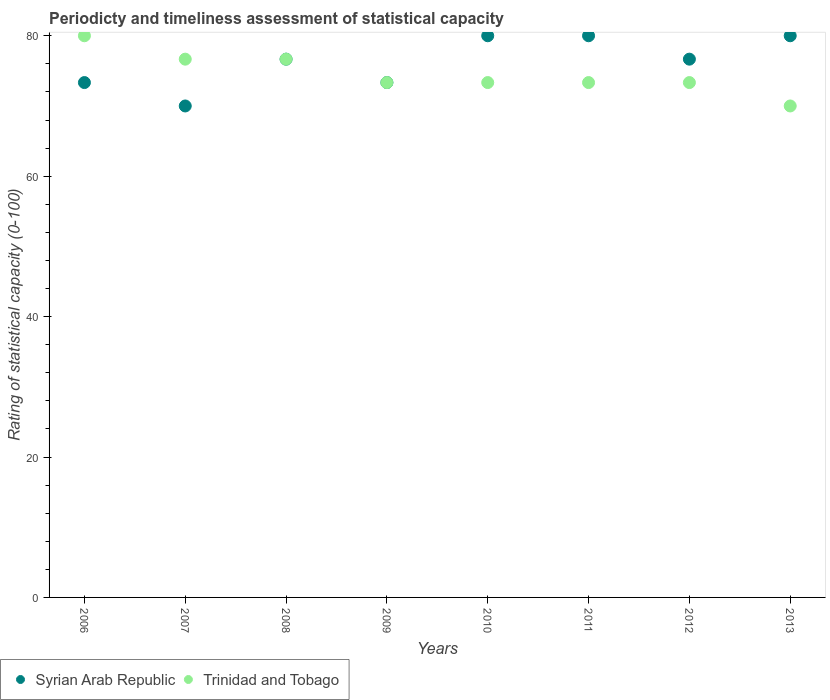Is the number of dotlines equal to the number of legend labels?
Keep it short and to the point. Yes. What is the rating of statistical capacity in Trinidad and Tobago in 2006?
Make the answer very short. 80. What is the total rating of statistical capacity in Trinidad and Tobago in the graph?
Your answer should be very brief. 596.67. What is the difference between the rating of statistical capacity in Trinidad and Tobago in 2006 and that in 2008?
Make the answer very short. 3.33. What is the difference between the rating of statistical capacity in Syrian Arab Republic in 2007 and the rating of statistical capacity in Trinidad and Tobago in 2010?
Offer a very short reply. -3.33. What is the average rating of statistical capacity in Syrian Arab Republic per year?
Your answer should be very brief. 76.25. In the year 2012, what is the difference between the rating of statistical capacity in Trinidad and Tobago and rating of statistical capacity in Syrian Arab Republic?
Your answer should be very brief. -3.33. What is the ratio of the rating of statistical capacity in Syrian Arab Republic in 2007 to that in 2010?
Make the answer very short. 0.88. Is the rating of statistical capacity in Trinidad and Tobago in 2006 less than that in 2007?
Your answer should be very brief. No. Is the difference between the rating of statistical capacity in Trinidad and Tobago in 2011 and 2012 greater than the difference between the rating of statistical capacity in Syrian Arab Republic in 2011 and 2012?
Make the answer very short. No. What is the difference between the highest and the second highest rating of statistical capacity in Syrian Arab Republic?
Keep it short and to the point. 0. What is the difference between the highest and the lowest rating of statistical capacity in Syrian Arab Republic?
Give a very brief answer. 10. In how many years, is the rating of statistical capacity in Trinidad and Tobago greater than the average rating of statistical capacity in Trinidad and Tobago taken over all years?
Offer a terse response. 3. Is the rating of statistical capacity in Trinidad and Tobago strictly less than the rating of statistical capacity in Syrian Arab Republic over the years?
Offer a very short reply. No. What is the difference between two consecutive major ticks on the Y-axis?
Your answer should be very brief. 20. Are the values on the major ticks of Y-axis written in scientific E-notation?
Offer a terse response. No. Where does the legend appear in the graph?
Keep it short and to the point. Bottom left. How many legend labels are there?
Make the answer very short. 2. How are the legend labels stacked?
Ensure brevity in your answer.  Horizontal. What is the title of the graph?
Provide a succinct answer. Periodicty and timeliness assessment of statistical capacity. What is the label or title of the X-axis?
Your answer should be very brief. Years. What is the label or title of the Y-axis?
Make the answer very short. Rating of statistical capacity (0-100). What is the Rating of statistical capacity (0-100) in Syrian Arab Republic in 2006?
Your answer should be very brief. 73.33. What is the Rating of statistical capacity (0-100) of Syrian Arab Republic in 2007?
Ensure brevity in your answer.  70. What is the Rating of statistical capacity (0-100) in Trinidad and Tobago in 2007?
Provide a short and direct response. 76.67. What is the Rating of statistical capacity (0-100) in Syrian Arab Republic in 2008?
Your answer should be very brief. 76.67. What is the Rating of statistical capacity (0-100) in Trinidad and Tobago in 2008?
Provide a succinct answer. 76.67. What is the Rating of statistical capacity (0-100) of Syrian Arab Republic in 2009?
Ensure brevity in your answer.  73.33. What is the Rating of statistical capacity (0-100) of Trinidad and Tobago in 2009?
Give a very brief answer. 73.33. What is the Rating of statistical capacity (0-100) in Syrian Arab Republic in 2010?
Make the answer very short. 80. What is the Rating of statistical capacity (0-100) in Trinidad and Tobago in 2010?
Offer a terse response. 73.33. What is the Rating of statistical capacity (0-100) of Syrian Arab Republic in 2011?
Ensure brevity in your answer.  80. What is the Rating of statistical capacity (0-100) of Trinidad and Tobago in 2011?
Your answer should be very brief. 73.33. What is the Rating of statistical capacity (0-100) in Syrian Arab Republic in 2012?
Give a very brief answer. 76.67. What is the Rating of statistical capacity (0-100) in Trinidad and Tobago in 2012?
Provide a succinct answer. 73.33. What is the Rating of statistical capacity (0-100) of Syrian Arab Republic in 2013?
Your response must be concise. 80. What is the Rating of statistical capacity (0-100) of Trinidad and Tobago in 2013?
Ensure brevity in your answer.  70. Across all years, what is the maximum Rating of statistical capacity (0-100) of Trinidad and Tobago?
Offer a terse response. 80. Across all years, what is the minimum Rating of statistical capacity (0-100) of Syrian Arab Republic?
Offer a terse response. 70. Across all years, what is the minimum Rating of statistical capacity (0-100) in Trinidad and Tobago?
Your answer should be very brief. 70. What is the total Rating of statistical capacity (0-100) in Syrian Arab Republic in the graph?
Give a very brief answer. 610. What is the total Rating of statistical capacity (0-100) in Trinidad and Tobago in the graph?
Make the answer very short. 596.67. What is the difference between the Rating of statistical capacity (0-100) in Syrian Arab Republic in 2006 and that in 2007?
Provide a succinct answer. 3.33. What is the difference between the Rating of statistical capacity (0-100) of Trinidad and Tobago in 2006 and that in 2007?
Your answer should be very brief. 3.33. What is the difference between the Rating of statistical capacity (0-100) in Syrian Arab Republic in 2006 and that in 2008?
Provide a short and direct response. -3.33. What is the difference between the Rating of statistical capacity (0-100) in Syrian Arab Republic in 2006 and that in 2010?
Offer a terse response. -6.67. What is the difference between the Rating of statistical capacity (0-100) in Syrian Arab Republic in 2006 and that in 2011?
Offer a very short reply. -6.67. What is the difference between the Rating of statistical capacity (0-100) of Trinidad and Tobago in 2006 and that in 2011?
Provide a short and direct response. 6.67. What is the difference between the Rating of statistical capacity (0-100) of Syrian Arab Republic in 2006 and that in 2012?
Your answer should be very brief. -3.33. What is the difference between the Rating of statistical capacity (0-100) in Syrian Arab Republic in 2006 and that in 2013?
Offer a terse response. -6.67. What is the difference between the Rating of statistical capacity (0-100) of Trinidad and Tobago in 2006 and that in 2013?
Your answer should be compact. 10. What is the difference between the Rating of statistical capacity (0-100) in Syrian Arab Republic in 2007 and that in 2008?
Offer a very short reply. -6.67. What is the difference between the Rating of statistical capacity (0-100) of Trinidad and Tobago in 2007 and that in 2009?
Your response must be concise. 3.33. What is the difference between the Rating of statistical capacity (0-100) of Syrian Arab Republic in 2007 and that in 2010?
Give a very brief answer. -10. What is the difference between the Rating of statistical capacity (0-100) in Trinidad and Tobago in 2007 and that in 2010?
Make the answer very short. 3.33. What is the difference between the Rating of statistical capacity (0-100) of Syrian Arab Republic in 2007 and that in 2011?
Make the answer very short. -10. What is the difference between the Rating of statistical capacity (0-100) in Syrian Arab Republic in 2007 and that in 2012?
Your answer should be very brief. -6.67. What is the difference between the Rating of statistical capacity (0-100) of Syrian Arab Republic in 2008 and that in 2009?
Offer a very short reply. 3.33. What is the difference between the Rating of statistical capacity (0-100) in Trinidad and Tobago in 2008 and that in 2009?
Your answer should be compact. 3.33. What is the difference between the Rating of statistical capacity (0-100) in Syrian Arab Republic in 2008 and that in 2010?
Keep it short and to the point. -3.33. What is the difference between the Rating of statistical capacity (0-100) in Trinidad and Tobago in 2008 and that in 2010?
Your response must be concise. 3.33. What is the difference between the Rating of statistical capacity (0-100) of Trinidad and Tobago in 2008 and that in 2011?
Your response must be concise. 3.33. What is the difference between the Rating of statistical capacity (0-100) of Syrian Arab Republic in 2008 and that in 2013?
Your answer should be very brief. -3.33. What is the difference between the Rating of statistical capacity (0-100) of Trinidad and Tobago in 2008 and that in 2013?
Your response must be concise. 6.67. What is the difference between the Rating of statistical capacity (0-100) of Syrian Arab Republic in 2009 and that in 2010?
Your answer should be compact. -6.67. What is the difference between the Rating of statistical capacity (0-100) of Trinidad and Tobago in 2009 and that in 2010?
Your response must be concise. 0. What is the difference between the Rating of statistical capacity (0-100) of Syrian Arab Republic in 2009 and that in 2011?
Provide a short and direct response. -6.67. What is the difference between the Rating of statistical capacity (0-100) of Trinidad and Tobago in 2009 and that in 2011?
Your answer should be very brief. 0. What is the difference between the Rating of statistical capacity (0-100) in Syrian Arab Republic in 2009 and that in 2013?
Your answer should be very brief. -6.67. What is the difference between the Rating of statistical capacity (0-100) of Trinidad and Tobago in 2009 and that in 2013?
Offer a very short reply. 3.33. What is the difference between the Rating of statistical capacity (0-100) of Trinidad and Tobago in 2010 and that in 2011?
Your answer should be very brief. 0. What is the difference between the Rating of statistical capacity (0-100) in Syrian Arab Republic in 2010 and that in 2012?
Provide a short and direct response. 3.33. What is the difference between the Rating of statistical capacity (0-100) in Syrian Arab Republic in 2011 and that in 2012?
Offer a very short reply. 3.33. What is the difference between the Rating of statistical capacity (0-100) in Trinidad and Tobago in 2011 and that in 2012?
Provide a short and direct response. 0. What is the difference between the Rating of statistical capacity (0-100) in Syrian Arab Republic in 2011 and that in 2013?
Ensure brevity in your answer.  0. What is the difference between the Rating of statistical capacity (0-100) of Syrian Arab Republic in 2006 and the Rating of statistical capacity (0-100) of Trinidad and Tobago in 2010?
Offer a very short reply. 0. What is the difference between the Rating of statistical capacity (0-100) in Syrian Arab Republic in 2006 and the Rating of statistical capacity (0-100) in Trinidad and Tobago in 2011?
Keep it short and to the point. 0. What is the difference between the Rating of statistical capacity (0-100) of Syrian Arab Republic in 2007 and the Rating of statistical capacity (0-100) of Trinidad and Tobago in 2008?
Provide a short and direct response. -6.67. What is the difference between the Rating of statistical capacity (0-100) of Syrian Arab Republic in 2007 and the Rating of statistical capacity (0-100) of Trinidad and Tobago in 2012?
Offer a very short reply. -3.33. What is the difference between the Rating of statistical capacity (0-100) of Syrian Arab Republic in 2008 and the Rating of statistical capacity (0-100) of Trinidad and Tobago in 2009?
Keep it short and to the point. 3.33. What is the difference between the Rating of statistical capacity (0-100) in Syrian Arab Republic in 2008 and the Rating of statistical capacity (0-100) in Trinidad and Tobago in 2011?
Keep it short and to the point. 3.33. What is the difference between the Rating of statistical capacity (0-100) in Syrian Arab Republic in 2009 and the Rating of statistical capacity (0-100) in Trinidad and Tobago in 2010?
Your answer should be very brief. 0. What is the difference between the Rating of statistical capacity (0-100) in Syrian Arab Republic in 2009 and the Rating of statistical capacity (0-100) in Trinidad and Tobago in 2012?
Give a very brief answer. 0. What is the difference between the Rating of statistical capacity (0-100) of Syrian Arab Republic in 2009 and the Rating of statistical capacity (0-100) of Trinidad and Tobago in 2013?
Ensure brevity in your answer.  3.33. What is the difference between the Rating of statistical capacity (0-100) in Syrian Arab Republic in 2010 and the Rating of statistical capacity (0-100) in Trinidad and Tobago in 2011?
Provide a short and direct response. 6.67. What is the difference between the Rating of statistical capacity (0-100) in Syrian Arab Republic in 2010 and the Rating of statistical capacity (0-100) in Trinidad and Tobago in 2012?
Offer a very short reply. 6.67. What is the difference between the Rating of statistical capacity (0-100) of Syrian Arab Republic in 2010 and the Rating of statistical capacity (0-100) of Trinidad and Tobago in 2013?
Your answer should be very brief. 10. What is the difference between the Rating of statistical capacity (0-100) of Syrian Arab Republic in 2011 and the Rating of statistical capacity (0-100) of Trinidad and Tobago in 2012?
Offer a terse response. 6.67. What is the difference between the Rating of statistical capacity (0-100) of Syrian Arab Republic in 2011 and the Rating of statistical capacity (0-100) of Trinidad and Tobago in 2013?
Provide a short and direct response. 10. What is the difference between the Rating of statistical capacity (0-100) of Syrian Arab Republic in 2012 and the Rating of statistical capacity (0-100) of Trinidad and Tobago in 2013?
Make the answer very short. 6.67. What is the average Rating of statistical capacity (0-100) of Syrian Arab Republic per year?
Offer a very short reply. 76.25. What is the average Rating of statistical capacity (0-100) of Trinidad and Tobago per year?
Provide a succinct answer. 74.58. In the year 2006, what is the difference between the Rating of statistical capacity (0-100) of Syrian Arab Republic and Rating of statistical capacity (0-100) of Trinidad and Tobago?
Ensure brevity in your answer.  -6.67. In the year 2007, what is the difference between the Rating of statistical capacity (0-100) of Syrian Arab Republic and Rating of statistical capacity (0-100) of Trinidad and Tobago?
Give a very brief answer. -6.67. In the year 2009, what is the difference between the Rating of statistical capacity (0-100) of Syrian Arab Republic and Rating of statistical capacity (0-100) of Trinidad and Tobago?
Provide a short and direct response. 0. In the year 2011, what is the difference between the Rating of statistical capacity (0-100) in Syrian Arab Republic and Rating of statistical capacity (0-100) in Trinidad and Tobago?
Your response must be concise. 6.67. In the year 2013, what is the difference between the Rating of statistical capacity (0-100) in Syrian Arab Republic and Rating of statistical capacity (0-100) in Trinidad and Tobago?
Your answer should be compact. 10. What is the ratio of the Rating of statistical capacity (0-100) of Syrian Arab Republic in 2006 to that in 2007?
Provide a succinct answer. 1.05. What is the ratio of the Rating of statistical capacity (0-100) in Trinidad and Tobago in 2006 to that in 2007?
Offer a very short reply. 1.04. What is the ratio of the Rating of statistical capacity (0-100) in Syrian Arab Republic in 2006 to that in 2008?
Your answer should be very brief. 0.96. What is the ratio of the Rating of statistical capacity (0-100) in Trinidad and Tobago in 2006 to that in 2008?
Provide a short and direct response. 1.04. What is the ratio of the Rating of statistical capacity (0-100) in Syrian Arab Republic in 2006 to that in 2009?
Keep it short and to the point. 1. What is the ratio of the Rating of statistical capacity (0-100) of Trinidad and Tobago in 2006 to that in 2009?
Keep it short and to the point. 1.09. What is the ratio of the Rating of statistical capacity (0-100) in Syrian Arab Republic in 2006 to that in 2012?
Your answer should be very brief. 0.96. What is the ratio of the Rating of statistical capacity (0-100) of Trinidad and Tobago in 2006 to that in 2013?
Offer a very short reply. 1.14. What is the ratio of the Rating of statistical capacity (0-100) of Trinidad and Tobago in 2007 to that in 2008?
Your answer should be very brief. 1. What is the ratio of the Rating of statistical capacity (0-100) of Syrian Arab Republic in 2007 to that in 2009?
Provide a succinct answer. 0.95. What is the ratio of the Rating of statistical capacity (0-100) of Trinidad and Tobago in 2007 to that in 2009?
Keep it short and to the point. 1.05. What is the ratio of the Rating of statistical capacity (0-100) of Trinidad and Tobago in 2007 to that in 2010?
Offer a terse response. 1.05. What is the ratio of the Rating of statistical capacity (0-100) in Trinidad and Tobago in 2007 to that in 2011?
Make the answer very short. 1.05. What is the ratio of the Rating of statistical capacity (0-100) of Trinidad and Tobago in 2007 to that in 2012?
Your answer should be very brief. 1.05. What is the ratio of the Rating of statistical capacity (0-100) in Syrian Arab Republic in 2007 to that in 2013?
Keep it short and to the point. 0.88. What is the ratio of the Rating of statistical capacity (0-100) in Trinidad and Tobago in 2007 to that in 2013?
Ensure brevity in your answer.  1.1. What is the ratio of the Rating of statistical capacity (0-100) in Syrian Arab Republic in 2008 to that in 2009?
Offer a terse response. 1.05. What is the ratio of the Rating of statistical capacity (0-100) in Trinidad and Tobago in 2008 to that in 2009?
Ensure brevity in your answer.  1.05. What is the ratio of the Rating of statistical capacity (0-100) in Trinidad and Tobago in 2008 to that in 2010?
Offer a very short reply. 1.05. What is the ratio of the Rating of statistical capacity (0-100) of Trinidad and Tobago in 2008 to that in 2011?
Your answer should be very brief. 1.05. What is the ratio of the Rating of statistical capacity (0-100) of Syrian Arab Republic in 2008 to that in 2012?
Provide a short and direct response. 1. What is the ratio of the Rating of statistical capacity (0-100) in Trinidad and Tobago in 2008 to that in 2012?
Give a very brief answer. 1.05. What is the ratio of the Rating of statistical capacity (0-100) in Syrian Arab Republic in 2008 to that in 2013?
Give a very brief answer. 0.96. What is the ratio of the Rating of statistical capacity (0-100) of Trinidad and Tobago in 2008 to that in 2013?
Make the answer very short. 1.1. What is the ratio of the Rating of statistical capacity (0-100) in Trinidad and Tobago in 2009 to that in 2010?
Make the answer very short. 1. What is the ratio of the Rating of statistical capacity (0-100) in Syrian Arab Republic in 2009 to that in 2012?
Your answer should be compact. 0.96. What is the ratio of the Rating of statistical capacity (0-100) of Syrian Arab Republic in 2009 to that in 2013?
Offer a very short reply. 0.92. What is the ratio of the Rating of statistical capacity (0-100) in Trinidad and Tobago in 2009 to that in 2013?
Offer a terse response. 1.05. What is the ratio of the Rating of statistical capacity (0-100) in Syrian Arab Republic in 2010 to that in 2011?
Offer a terse response. 1. What is the ratio of the Rating of statistical capacity (0-100) of Syrian Arab Republic in 2010 to that in 2012?
Your answer should be very brief. 1.04. What is the ratio of the Rating of statistical capacity (0-100) in Trinidad and Tobago in 2010 to that in 2013?
Your answer should be compact. 1.05. What is the ratio of the Rating of statistical capacity (0-100) of Syrian Arab Republic in 2011 to that in 2012?
Offer a terse response. 1.04. What is the ratio of the Rating of statistical capacity (0-100) in Trinidad and Tobago in 2011 to that in 2013?
Your answer should be compact. 1.05. What is the ratio of the Rating of statistical capacity (0-100) in Trinidad and Tobago in 2012 to that in 2013?
Provide a succinct answer. 1.05. 